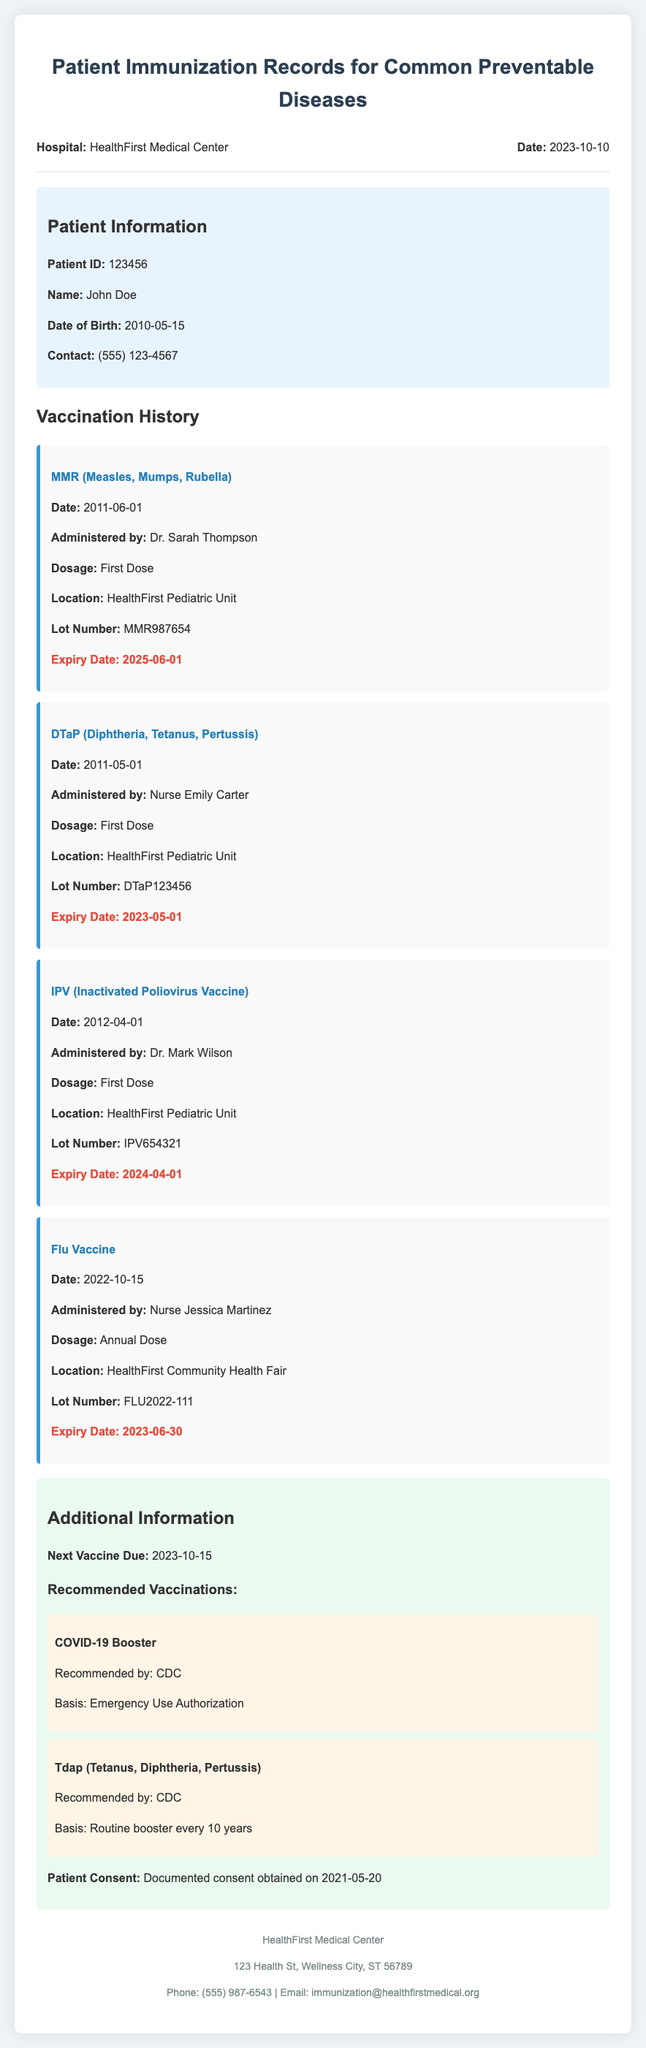what is the patient's name? The patient's name is listed under Patient Information in the document.
Answer: John Doe when was the MMR vaccine administered? The date of administration for the MMR vaccine is shown in its vaccine record.
Answer: 2011-06-01 who administered the DTaP vaccine? The name of the individual who administered the DTaP vaccine is specified in its record.
Answer: Nurse Emily Carter what is the expiry date of the Flu Vaccine? The expiry date is provided in the vaccine record section for the Flu Vaccine.
Answer: 2023-06-30 what is the next vaccine due for this patient? The document indicates the next vaccine due under Additional Information.
Answer: 2023-10-15 how many vaccines has the patient received? The number of vaccine records in the document provides the total count of vaccines administered.
Answer: Four what recommended vaccination is mentioned? The recommendations section lists vaccines that are suggested for the patient.
Answer: COVID-19 Booster what is the basis for the COVID-19 Booster recommendation? The basis for the recommendation is mentioned in the Additional Information section.
Answer: Emergency Use Authorization who is the hospital providing the immunization records? The hospital name is provided in the header of the document.
Answer: HealthFirst Medical Center 